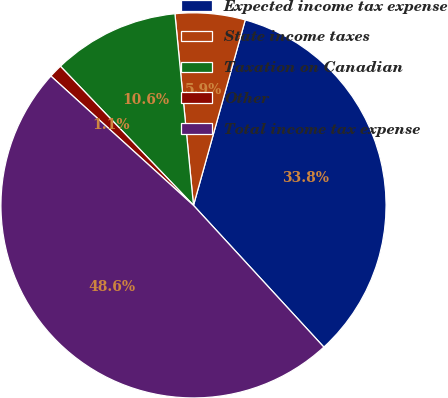Convert chart. <chart><loc_0><loc_0><loc_500><loc_500><pie_chart><fcel>Expected income tax expense<fcel>State income taxes<fcel>Taxation on Canadian<fcel>Other<fcel>Total income tax expense<nl><fcel>33.83%<fcel>5.87%<fcel>10.61%<fcel>1.13%<fcel>48.56%<nl></chart> 